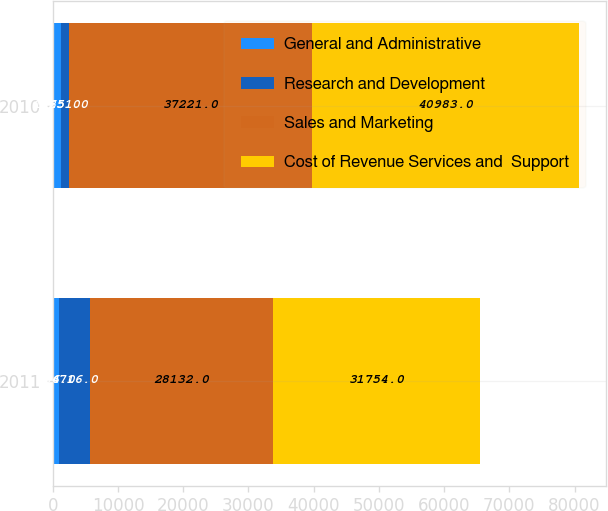Convert chart. <chart><loc_0><loc_0><loc_500><loc_500><stacked_bar_chart><ecel><fcel>2011<fcel>2010<nl><fcel>General and Administrative<fcel>936<fcel>1265<nl><fcel>Research and Development<fcel>4716<fcel>1251<nl><fcel>Sales and Marketing<fcel>28132<fcel>37221<nl><fcel>Cost of Revenue Services and  Support<fcel>31754<fcel>40983<nl></chart> 